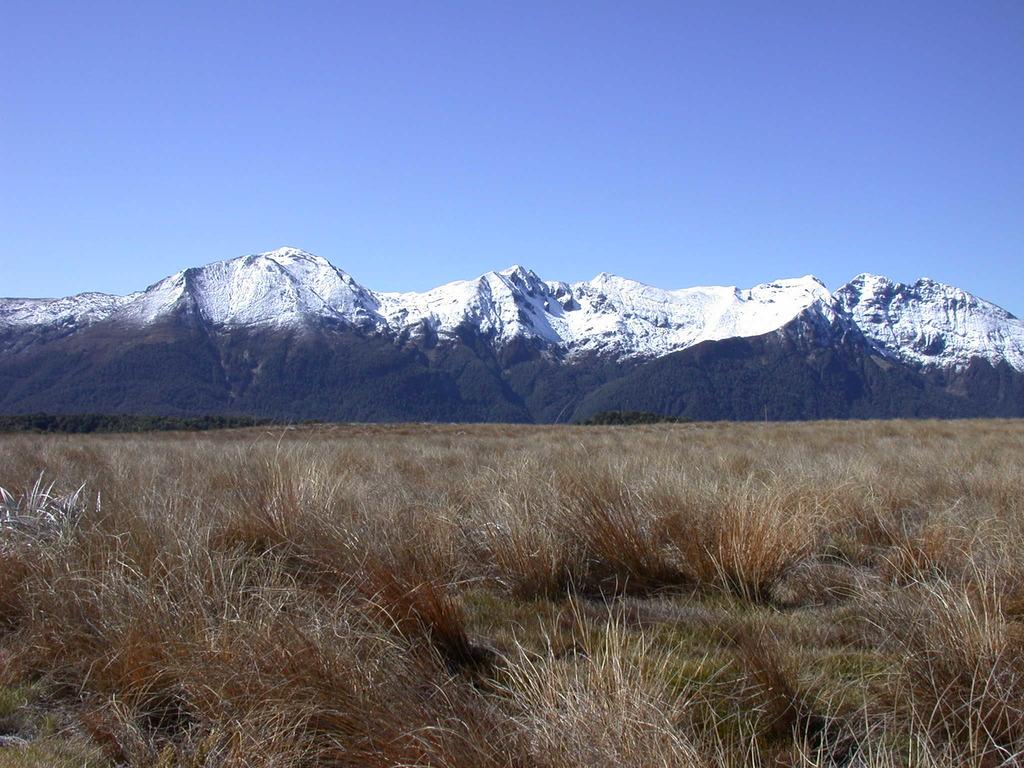What type of vegetation is present in the image? There is grass in the image. What natural feature can be seen in the distance? There are mountains in the background of the image. What is visible at the top of the image? The sky is visible at the top of the image. What type of calculator can be seen in the image? There is no calculator present in the image. Can you tell me the total amount on the receipt in the image? There is no receipt present in the image. 